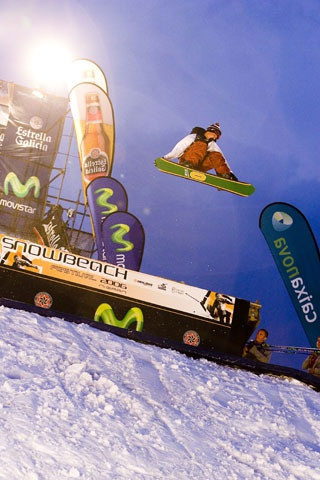Describe the objects in this image and their specific colors. I can see people in lavender, brown, maroon, lightgray, and black tones, snowboard in lavender, olive, gray, and tan tones, people in lavender, black, maroon, and brown tones, and people in lavender, maroon, black, and brown tones in this image. 